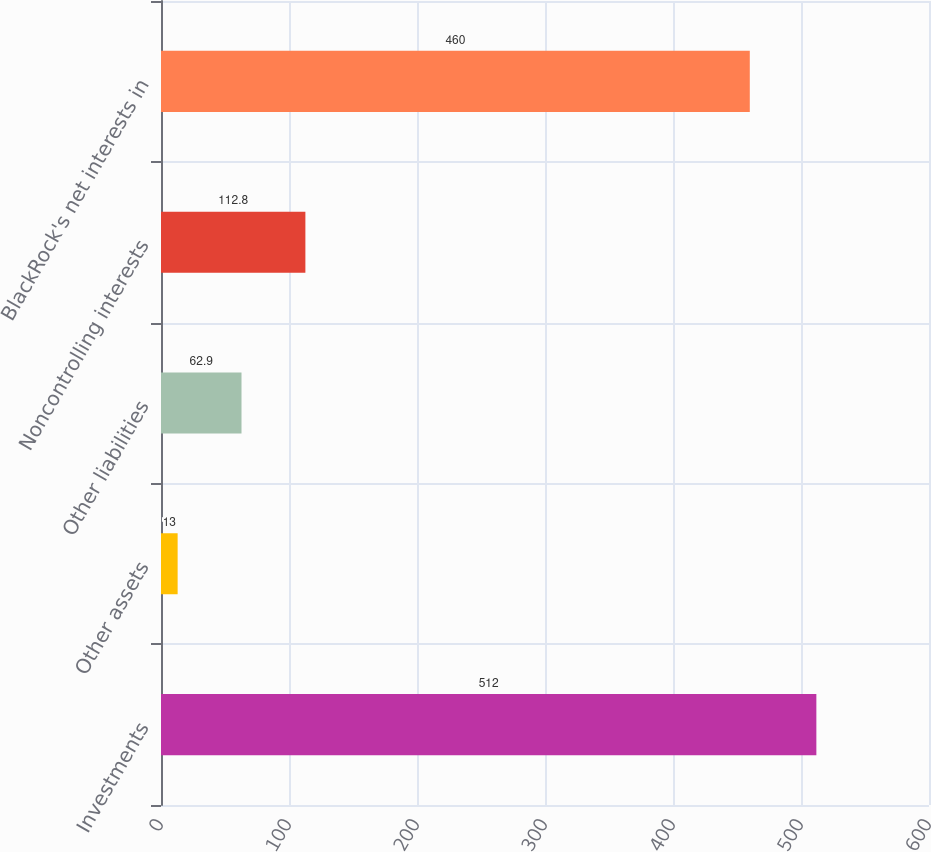<chart> <loc_0><loc_0><loc_500><loc_500><bar_chart><fcel>Investments<fcel>Other assets<fcel>Other liabilities<fcel>Noncontrolling interests<fcel>BlackRock's net interests in<nl><fcel>512<fcel>13<fcel>62.9<fcel>112.8<fcel>460<nl></chart> 